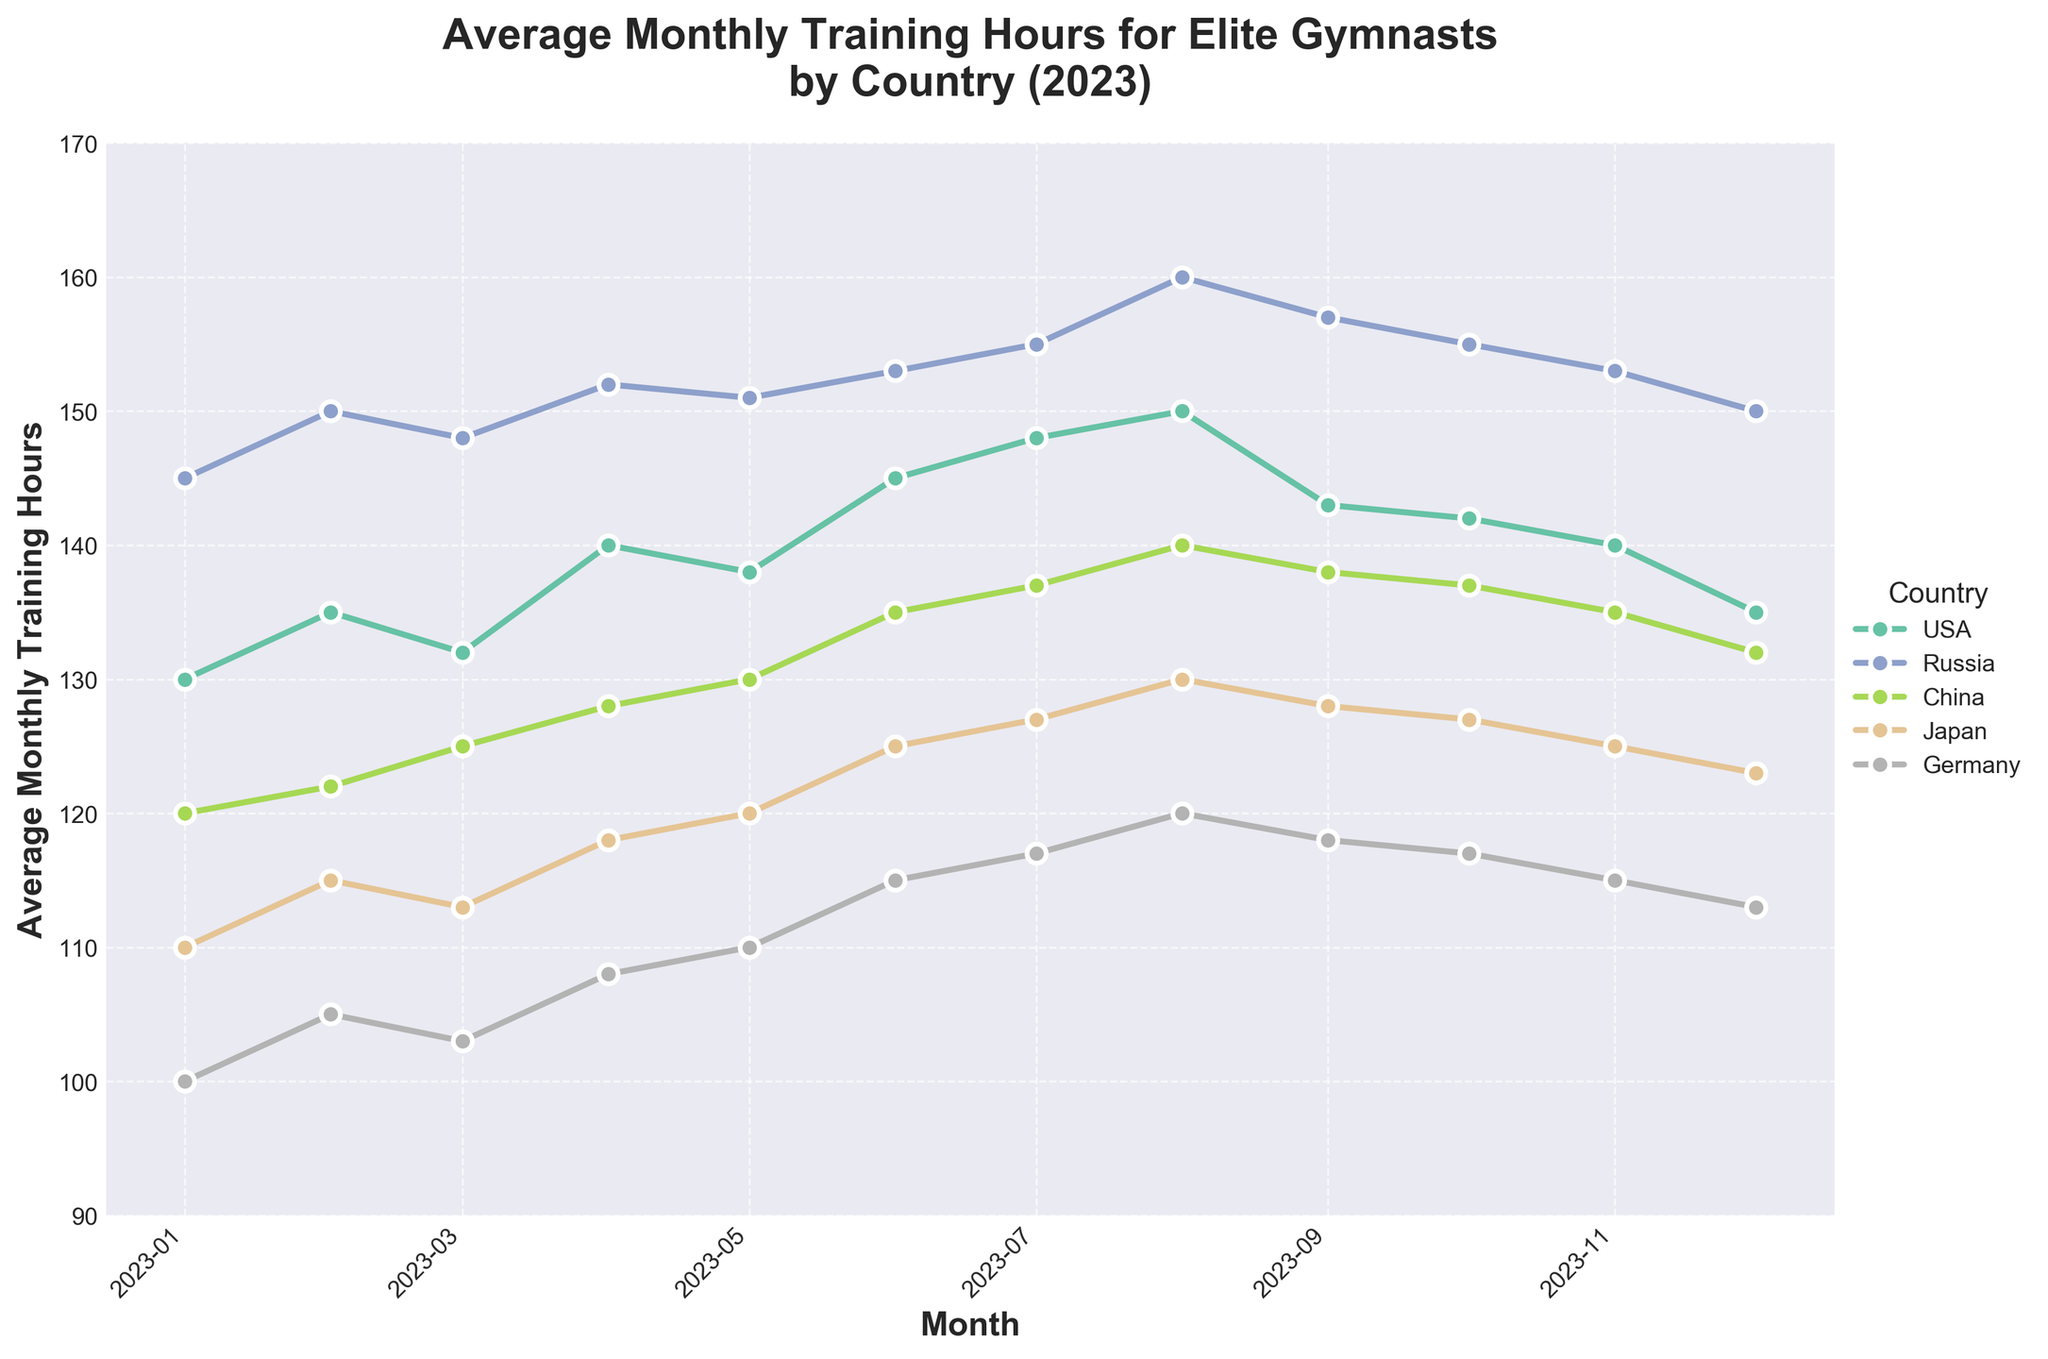What is the title of the plot? The title is located at the top of the figure and provides a summary of the data visualization. It reads "Average Monthly Training Hours for Elite Gymnasts by Country (2023)".
Answer: Average Monthly Training Hours for Elite Gymnasts by Country (2023) Which country had the highest average training hours in December 2023? From the plot, you can locate December 2023 on the x-axis and compare the y-axis values for each country. Russia has the highest average training hours.
Answer: Russia What is the average training hours for USA gymnasts in August 2023? By locating August 2023 on the x-axis and then checking the y-axis value for the USA, you can find the average training hours.
Answer: 150 How does the average training hours in February 2023 compare between Germany and Japan? Locate February 2023 on the x-axis, then compare the y-axis values for Germany and Japan. Germany has lower average training hours than Japan.
Answer: Germany: 105, Japan: 115 Did the average monthly training hours for China increase or decrease from January to December 2023? Check the y-axis values for China in January and December 2023. January has a lower value, and December is higher.
Answer: Increase What is the trend for average monthly training hours for gymnasts in USA over 2023? By observing the plot line for the USA from January to December, you can see that it starts relatively high, slightly fluctuates, peaks in August, and then decreases towards the end of the year.
Answer: Fluctuates but peaks in August Between which months did Russia experience the largest increase in average monthly training hours? Observe the plot for Russia and identify the months with the steepest upward slope. The largest increase is from July to August.
Answer: July to August What is the difference in training hours between the peak month and the lowest month for Germany? Identify the months with the highest and lowest y-axis values for Germany. The peak is in August (120) and the lowest is in January (100). The difference is 120 - 100.
Answer: 20 What general trend do you observe for most countries' average monthly training hours over the year 2023? By examining all countries' plots, you can notice that most countries' training hours generally increased towards the middle of the year and decreased slightly towards the end.
Answer: Increase mid-year, decrease towards end Which country had the steadiest increase in average monthly training hours throughout the year? By observing the smoothness and consistency of the slope for each country, China shows a more steady, consistent increase compared to others.
Answer: China 